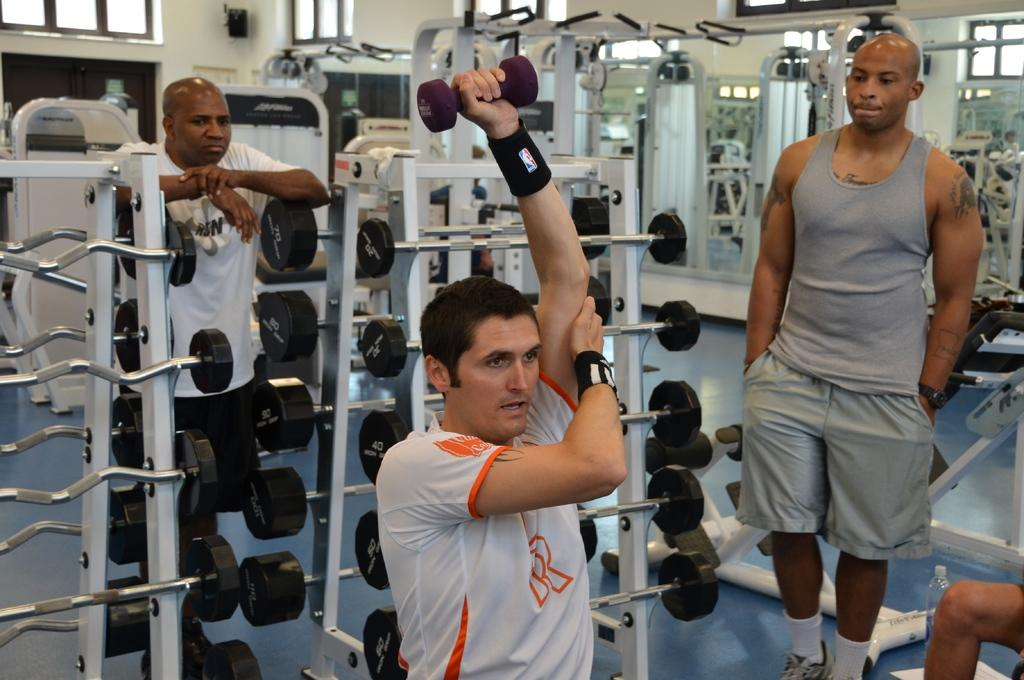Who is the main subject in the picture? There is a man in the picture. What is the man wearing? The man is wearing a white shirt. What is the man holding in his left hand? The man is holding a dumbbell in his left hand. Are there any other people in the picture? Yes, there are two other people in the picture. What are the two other people doing? The two other people are watching the man. What type of voyage are the people embarking on in the image? There is no indication of a voyage in the image; it features a man holding a dumbbell while being watched by two other people. What is the man using to cover his mouth in the image? There is no object covering the man's mouth in the image. 